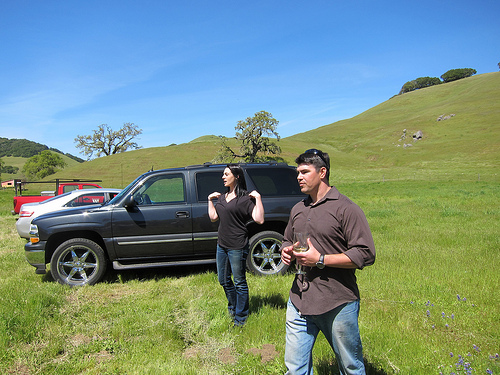<image>
Is the girl behind the guy? Yes. From this viewpoint, the girl is positioned behind the guy, with the guy partially or fully occluding the girl. 